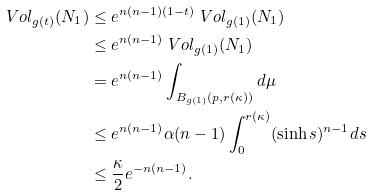Convert formula to latex. <formula><loc_0><loc_0><loc_500><loc_500>\ V o l _ { g ( t ) } ( N _ { 1 } ) & \leq e ^ { n ( n - 1 ) ( 1 - t ) } \ V o l _ { g ( 1 ) } ( N _ { 1 } ) \\ & \leq e ^ { n ( n - 1 ) } \ V o l _ { g ( 1 ) } ( N _ { 1 } ) \\ & = e ^ { n ( n - 1 ) } \int _ { B _ { g ( 1 ) } ( p , r ( \kappa ) ) } d \mu \\ & \leq e ^ { n ( n - 1 ) } \alpha ( n - 1 ) \int _ { 0 } ^ { r ( \kappa ) } ( \sinh s ) ^ { n - 1 } d s \\ & \leq \frac { \kappa } { 2 } e ^ { - n ( n - 1 ) } .</formula> 